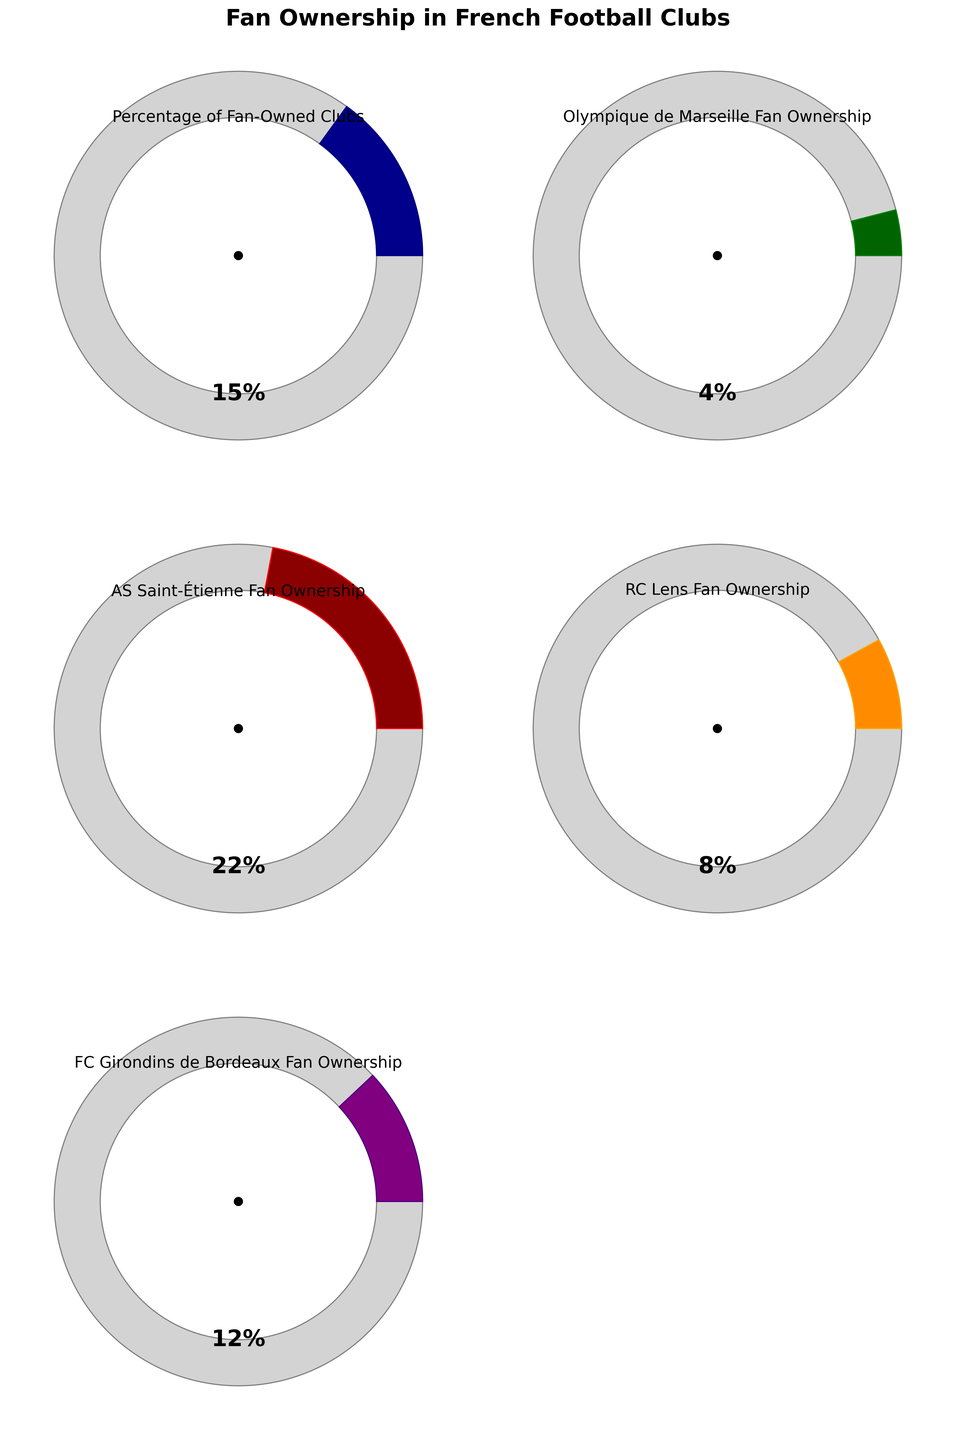What is the title of the figure? The title is usually at the top of the figure, and for this one, it is bold and large, indicating the main theme of the visualized data.
Answer: Fan Ownership in French Football Clubs How many football clubs are represented in the figure? By counting the number of gauge charts present in the figure, we can determine the number of football clubs represented. The figure shows five distinct gauge charts, each representing a football club.
Answer: Five Which football club has the highest percentage of fan ownership? Looking at the various percentages indicated within each gauge chart, we identify the club with the highest value. AS Saint-Étienne has 22%, which is the highest among the clubs.
Answer: AS Saint-Étienne What is the total percentage of fan ownership for all the clubs combined? Sum up the percentages from each gauge chart: 4% + 22% + 8% + 12%.
Answer: 46% How much lower is the fan ownership percentage of RC Lens compared to AS Saint-Étienne? Subtract the fan ownership percentage of RC Lens from that of AS Saint-Étienne: 22% - 8%.
Answer: 14% Which clubs have a fan ownership percentage greater than 10%? Identify gauge charts with values above 10%: AS Saint-Étienne and FC Girondins de Bordeaux have 22% and 12%, respectively.
Answer: AS Saint-Étienne, FC Girondins de Bordeaux Is Olympique de Marseille’s fan ownership percentage higher or lower than RC Lens’s? Compare the percentages directly: Olympique de Marseille (4%) and RC Lens (8%). Olympique de Marseille has a lower percentage.
Answer: Lower What is the average percentage of fan ownership across the five clubs? Calculate the mean by summing the percentages and dividing by the number of clubs: (4% + 22% + 8% + 12% + 15%)/5.
Answer: 12.2% Does any club have exactly 10% fan ownership? Check each gauge chart for a value of 10%. None of the charts display exactly 10%.
Answer: No 